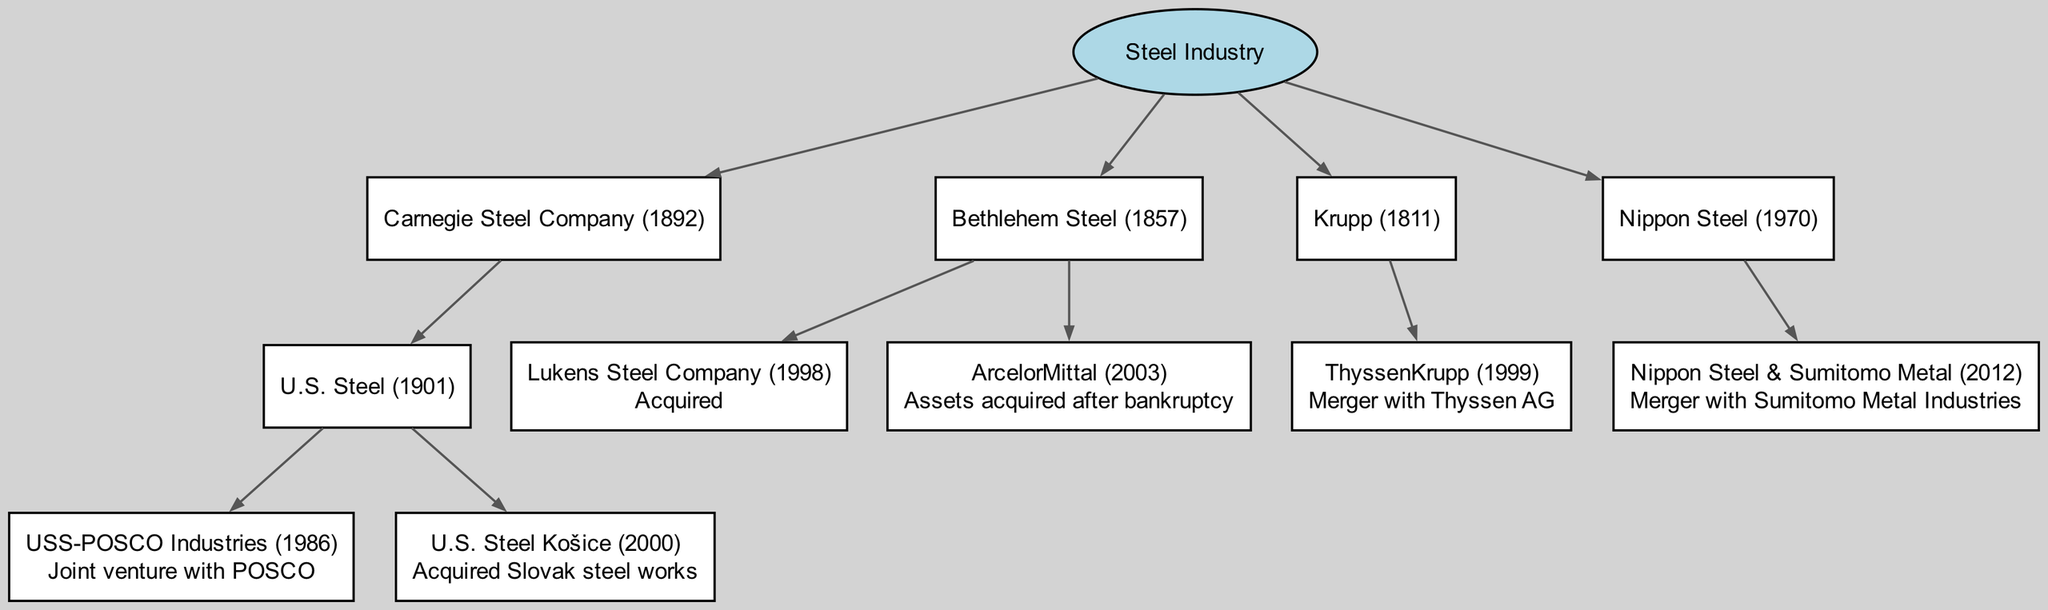What is the root of the family tree? The diagram clearly indicates the root node labeled as "Steel Industry." It acts as the main ancestor and the starting point for tracing the connections and relations.
Answer: Steel Industry How many major steel companies are in the tree? By examining the first level of child nodes directly under "Steel Industry," we can count the major companies listed, which are Carnegie Steel Company, Bethlehem Steel, Krupp, and Nippon Steel, resulting in a total of four companies.
Answer: 4 What is the name of the joint venture under U.S. Steel? By tracing the children of U.S. Steel, we find a node for USS-POSCO Industries, which is explicitly marked as a "Joint venture with POSCO." This indicates its connection and relationship to U.S. Steel.
Answer: USS-POSCO Industries Which company acquired Lukens Steel Company? Upon checking the children of Bethlehem Steel, we see that Lukens Steel Company is noted as "Acquired." This leads us to identify Bethlehem Steel as the company responsible for the acquisition.
Answer: Bethlehem Steel What year did U.S. Steel get established? Looking at the node representing U.S. Steel, it specifies the year it was established in parentheses "(1901)", giving us the exact founding year of the company.
Answer: 1901 What significant event occurred for Bethlehem Steel in 2003? In the Bethlehem Steel section, there’s a note stating "ArcelorMittal - Assets acquired after bankruptcy." This implies that 2003 was a notable year due to the company's bankruptcy and subsequent acquisition of its assets.
Answer: Assets acquired after bankruptcy How did Krupp become ThyssenKrupp? The diagram shows a merger indicated in the Krupp section as "Merger with Thyssen AG," which explains the transformation into ThyssenKrupp. This reflects the relationship between the two entities throughout their history.
Answer: Merger with Thyssen AG When did Nippon Steel & Sumitomo Metal form? The diagram provides the year for the merger between Nippon Steel and Sumitomo Metal Industries as "(2012)," clearly indicating the establishment of Nippon Steel & Sumitomo Metal.
Answer: 2012 Which company is associated with the Slovak steel works? The details under the U.S. Steel section clearly specify that U.S. Steel Košice, noted for the "Acquired Slovak steel works," is the company associated with this acquisition, linking it back to U.S. Steel.
Answer: U.S. Steel Košice 